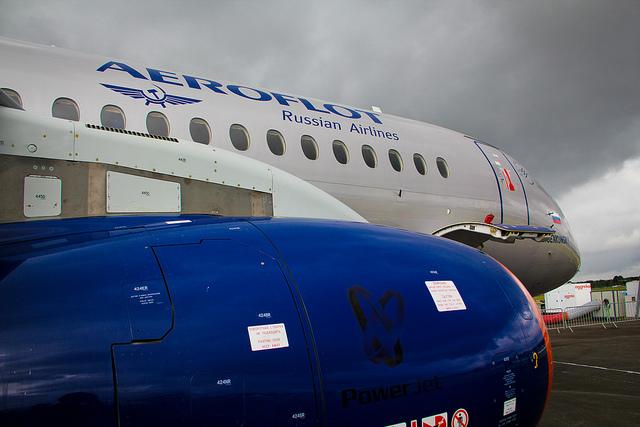What does the plane say?
Write a very short answer. Aeroflot russian airlines. What airlines are printed on the side of the plane?
Write a very short answer. Aeroflot. What color is the planes engine?
Write a very short answer. Blue. What color is the plane in there?
Quick response, please. White. 